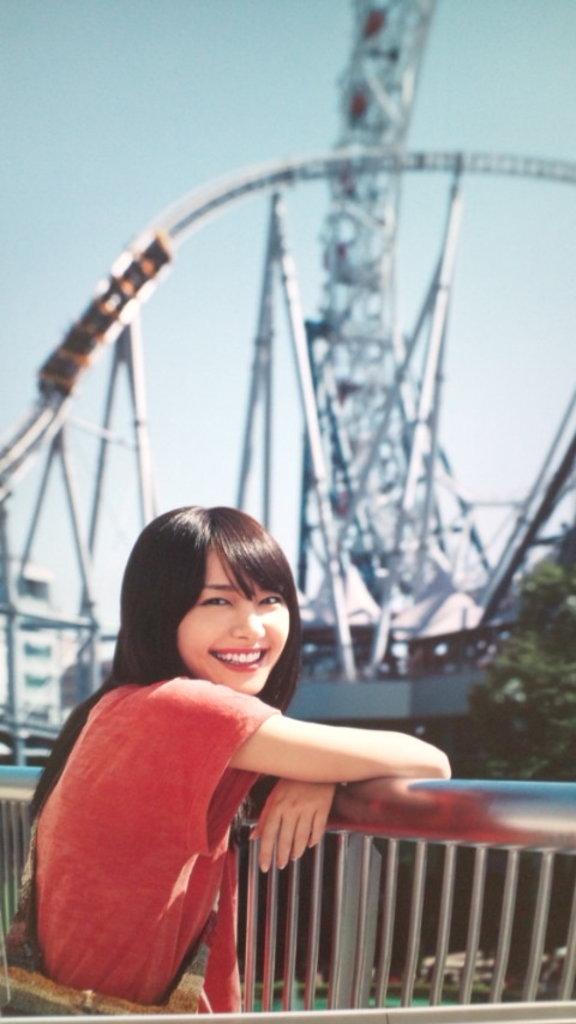Could you give a brief overview of what you see in this image? In this image we can see woman smiling and standing near the grills, roller coaster, trees and sky. 